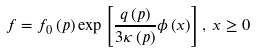Convert formula to latex. <formula><loc_0><loc_0><loc_500><loc_500>f = f _ { 0 } \left ( p \right ) \exp \left [ \frac { q \left ( p \right ) } { 3 \kappa \left ( p \right ) } \phi \left ( x \right ) \right ] , \, x \geq 0</formula> 